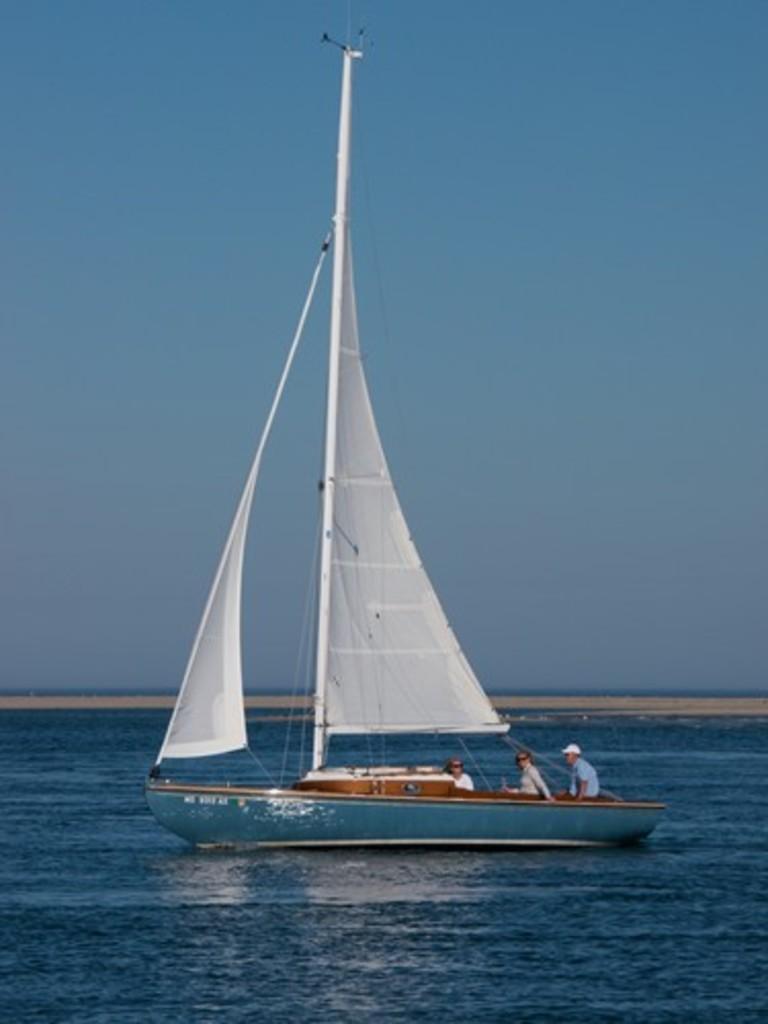Describe this image in one or two sentences. In the picture we can see a boat in the water, which is blue in color, on the boat we can see a pole and in the background we can see a sand surface and the sky. 